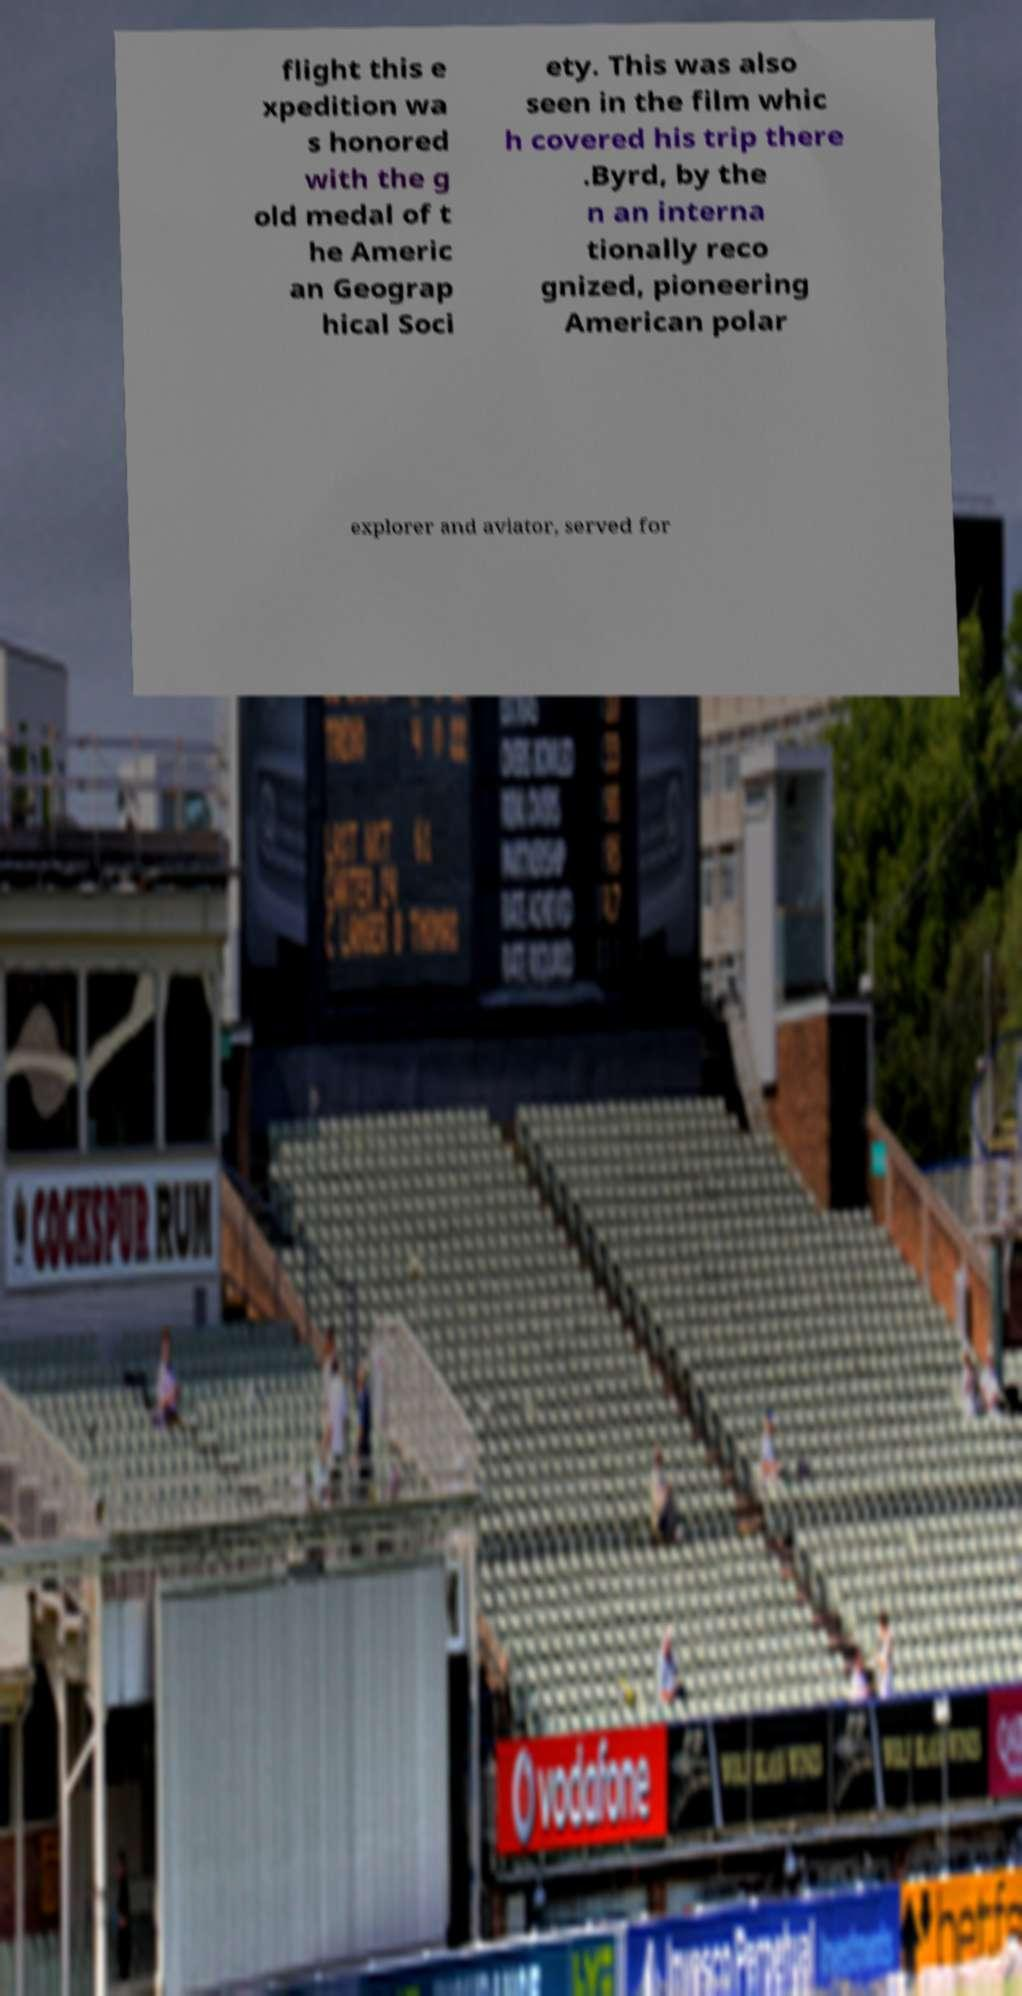Please identify and transcribe the text found in this image. flight this e xpedition wa s honored with the g old medal of t he Americ an Geograp hical Soci ety. This was also seen in the film whic h covered his trip there .Byrd, by the n an interna tionally reco gnized, pioneering American polar explorer and aviator, served for 